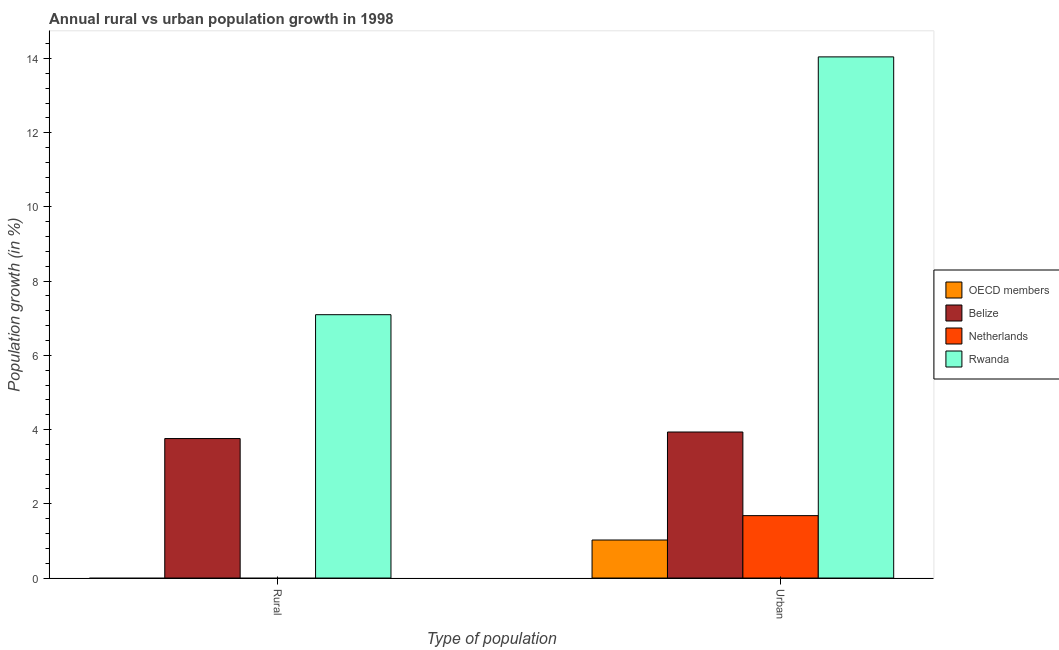How many different coloured bars are there?
Offer a terse response. 4. How many groups of bars are there?
Offer a very short reply. 2. How many bars are there on the 2nd tick from the left?
Ensure brevity in your answer.  4. How many bars are there on the 2nd tick from the right?
Keep it short and to the point. 2. What is the label of the 2nd group of bars from the left?
Your answer should be very brief. Urban . What is the urban population growth in Rwanda?
Ensure brevity in your answer.  14.04. Across all countries, what is the maximum rural population growth?
Your answer should be very brief. 7.1. In which country was the rural population growth maximum?
Give a very brief answer. Rwanda. What is the total urban population growth in the graph?
Make the answer very short. 20.68. What is the difference between the urban population growth in OECD members and that in Rwanda?
Your response must be concise. -13.02. What is the difference between the urban population growth in Belize and the rural population growth in Rwanda?
Your answer should be very brief. -3.16. What is the average rural population growth per country?
Offer a very short reply. 2.71. What is the difference between the rural population growth and urban population growth in Belize?
Provide a short and direct response. -0.18. What is the ratio of the urban population growth in OECD members to that in Belize?
Offer a very short reply. 0.26. Is the urban population growth in Belize less than that in OECD members?
Your answer should be compact. No. In how many countries, is the rural population growth greater than the average rural population growth taken over all countries?
Your answer should be compact. 2. How are the legend labels stacked?
Offer a very short reply. Vertical. What is the title of the graph?
Provide a succinct answer. Annual rural vs urban population growth in 1998. What is the label or title of the X-axis?
Provide a succinct answer. Type of population. What is the label or title of the Y-axis?
Make the answer very short. Population growth (in %). What is the Population growth (in %) of OECD members in Rural?
Offer a very short reply. 0. What is the Population growth (in %) of Belize in Rural?
Provide a short and direct response. 3.76. What is the Population growth (in %) in Netherlands in Rural?
Make the answer very short. 0. What is the Population growth (in %) of Rwanda in Rural?
Offer a very short reply. 7.1. What is the Population growth (in %) of OECD members in Urban ?
Keep it short and to the point. 1.02. What is the Population growth (in %) of Belize in Urban ?
Provide a short and direct response. 3.93. What is the Population growth (in %) in Netherlands in Urban ?
Make the answer very short. 1.68. What is the Population growth (in %) of Rwanda in Urban ?
Offer a very short reply. 14.04. Across all Type of population, what is the maximum Population growth (in %) of OECD members?
Offer a terse response. 1.02. Across all Type of population, what is the maximum Population growth (in %) in Belize?
Provide a short and direct response. 3.93. Across all Type of population, what is the maximum Population growth (in %) of Netherlands?
Keep it short and to the point. 1.68. Across all Type of population, what is the maximum Population growth (in %) in Rwanda?
Your response must be concise. 14.04. Across all Type of population, what is the minimum Population growth (in %) in OECD members?
Provide a succinct answer. 0. Across all Type of population, what is the minimum Population growth (in %) in Belize?
Provide a succinct answer. 3.76. Across all Type of population, what is the minimum Population growth (in %) of Netherlands?
Your answer should be compact. 0. Across all Type of population, what is the minimum Population growth (in %) of Rwanda?
Give a very brief answer. 7.1. What is the total Population growth (in %) in OECD members in the graph?
Your response must be concise. 1.02. What is the total Population growth (in %) in Belize in the graph?
Offer a very short reply. 7.69. What is the total Population growth (in %) in Netherlands in the graph?
Offer a very short reply. 1.68. What is the total Population growth (in %) of Rwanda in the graph?
Make the answer very short. 21.14. What is the difference between the Population growth (in %) of Belize in Rural and that in Urban ?
Make the answer very short. -0.18. What is the difference between the Population growth (in %) in Rwanda in Rural and that in Urban ?
Offer a very short reply. -6.95. What is the difference between the Population growth (in %) of Belize in Rural and the Population growth (in %) of Netherlands in Urban?
Provide a succinct answer. 2.08. What is the difference between the Population growth (in %) of Belize in Rural and the Population growth (in %) of Rwanda in Urban?
Keep it short and to the point. -10.28. What is the average Population growth (in %) of OECD members per Type of population?
Provide a short and direct response. 0.51. What is the average Population growth (in %) in Belize per Type of population?
Provide a succinct answer. 3.85. What is the average Population growth (in %) of Netherlands per Type of population?
Provide a short and direct response. 0.84. What is the average Population growth (in %) in Rwanda per Type of population?
Make the answer very short. 10.57. What is the difference between the Population growth (in %) of Belize and Population growth (in %) of Rwanda in Rural?
Your response must be concise. -3.34. What is the difference between the Population growth (in %) in OECD members and Population growth (in %) in Belize in Urban ?
Your response must be concise. -2.91. What is the difference between the Population growth (in %) of OECD members and Population growth (in %) of Netherlands in Urban ?
Ensure brevity in your answer.  -0.66. What is the difference between the Population growth (in %) of OECD members and Population growth (in %) of Rwanda in Urban ?
Your answer should be very brief. -13.02. What is the difference between the Population growth (in %) in Belize and Population growth (in %) in Netherlands in Urban ?
Offer a very short reply. 2.25. What is the difference between the Population growth (in %) in Belize and Population growth (in %) in Rwanda in Urban ?
Ensure brevity in your answer.  -10.11. What is the difference between the Population growth (in %) in Netherlands and Population growth (in %) in Rwanda in Urban ?
Ensure brevity in your answer.  -12.36. What is the ratio of the Population growth (in %) in Belize in Rural to that in Urban ?
Provide a short and direct response. 0.96. What is the ratio of the Population growth (in %) of Rwanda in Rural to that in Urban ?
Your answer should be very brief. 0.51. What is the difference between the highest and the second highest Population growth (in %) of Belize?
Offer a terse response. 0.18. What is the difference between the highest and the second highest Population growth (in %) in Rwanda?
Provide a short and direct response. 6.95. What is the difference between the highest and the lowest Population growth (in %) of OECD members?
Provide a short and direct response. 1.02. What is the difference between the highest and the lowest Population growth (in %) of Belize?
Make the answer very short. 0.18. What is the difference between the highest and the lowest Population growth (in %) in Netherlands?
Your response must be concise. 1.68. What is the difference between the highest and the lowest Population growth (in %) in Rwanda?
Make the answer very short. 6.95. 